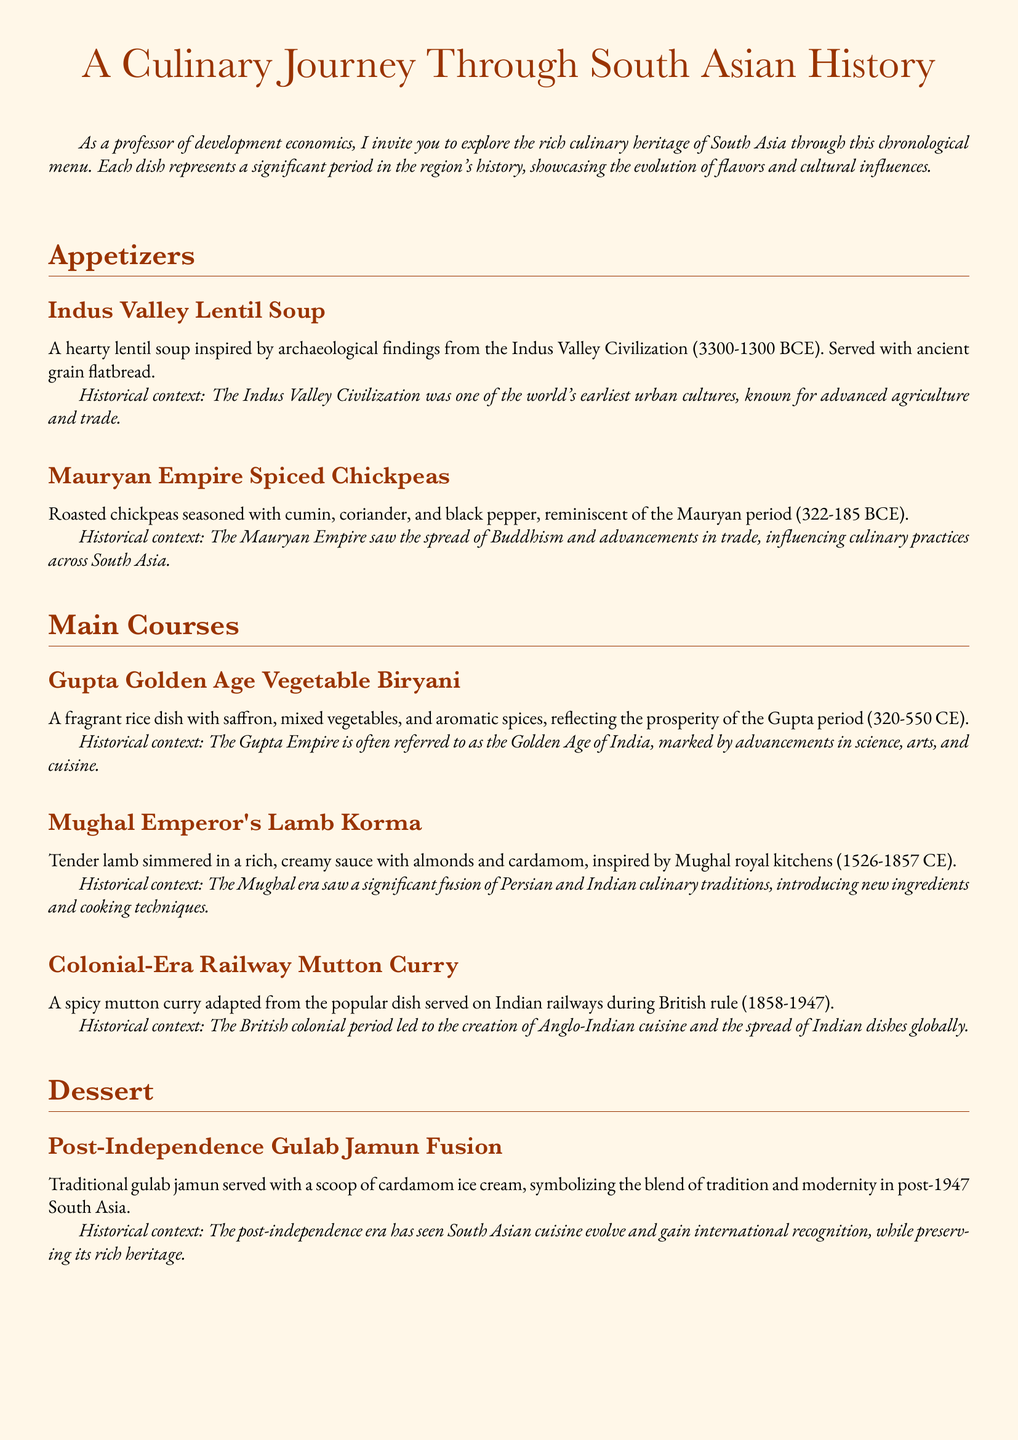What is the first appetizer listed? The first appetizer is identified in the menu's appetizers section and is "Indus Valley Lentil Soup."
Answer: Indus Valley Lentil Soup What historical period does the Mughal Emperor's Lamb Korma represent? The Mughal Emperor's Lamb Korma is associated with the Mughal royal kitchens, particularly the period from 1526 to 1857 CE.
Answer: 1526-1857 CE How many main courses are featured in this menu? The main courses section lists three distinct dishes, indicating the total number of main courses available.
Answer: 3 What is the dessert that symbolizes the blend of tradition and modernity? The dessert reflecting this theme is detailed in the dessert section of the menu.
Answer: Post-Independence Gulab Jamun Fusion What spice is mentioned in the beverage description? The beverage description includes "masala," which refers to a blend of spices used in the drink.
Answer: masala What type of cuisine emerged during the British colonial period? The document describes the impact of British colonial rule on culinary practices, highlighting the rise of a specific fusion.
Answer: Anglo-Indian cuisine What key ingredient is used in the Gupta Golden Age Vegetable Biryani? The description of this dish notes "saffron" as one of its key flavoring components.
Answer: saffron Which dish is inspired by archaeological findings? The menu states that the first appetizer is based on archaeological findings from a significant civilization.
Answer: Indus Valley Lentil Soup 